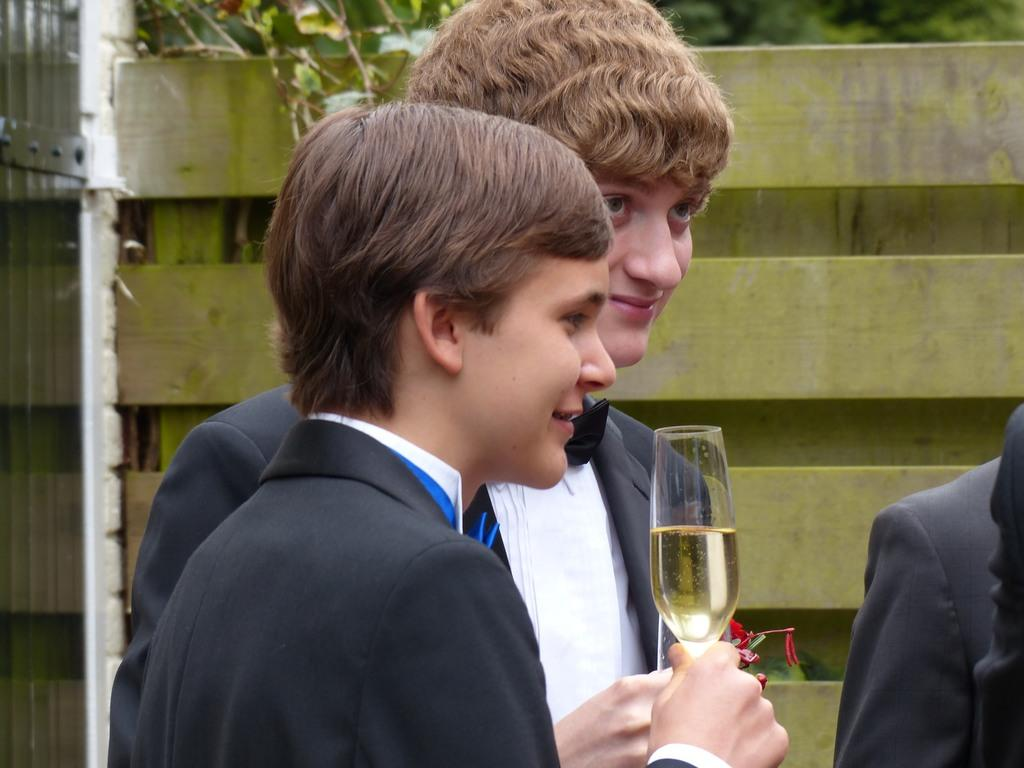How many boys are in the image? There are two boys in the image. What are the boys holding in their hands? Both boys are holding glasses. What expression do the boys have on their faces? The boys have smiles on their faces. What can be seen in the background of the image? There are trees and a wall in the background of the image. What type of drum can be seen in the image? There is no drum present in the image. Can you tell me how many stamps are on the wall in the image? There is no mention of stamps on the wall in the image. 